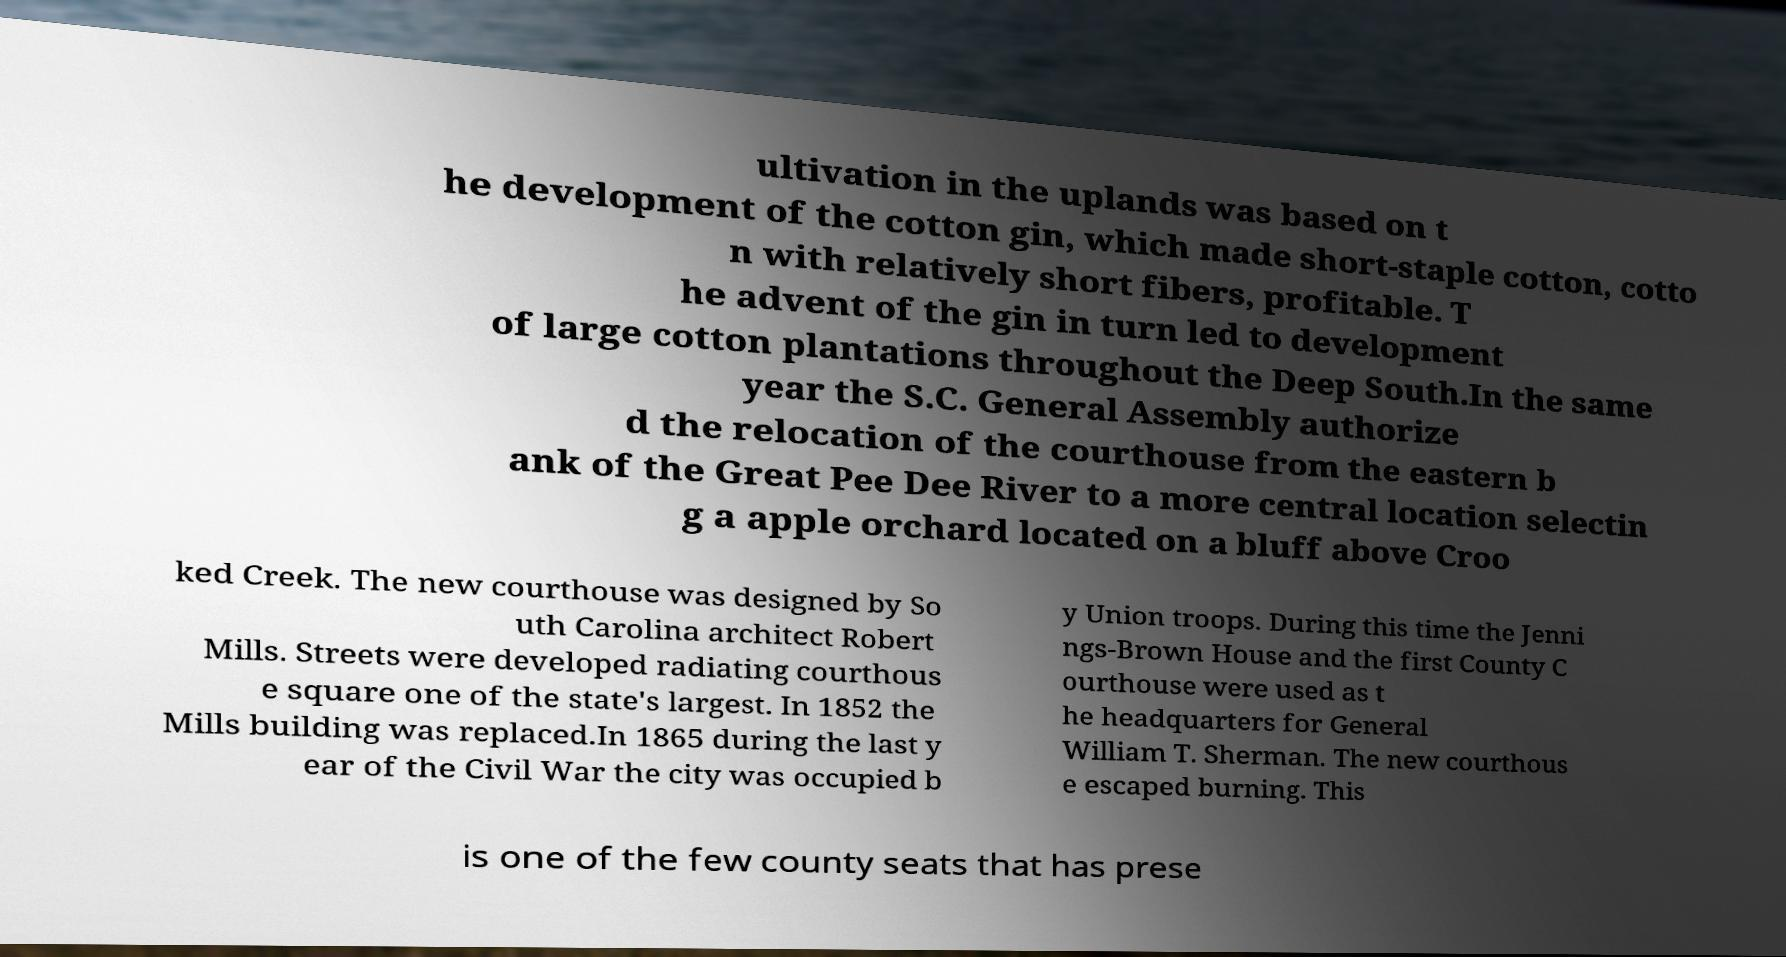What messages or text are displayed in this image? I need them in a readable, typed format. ultivation in the uplands was based on t he development of the cotton gin, which made short-staple cotton, cotto n with relatively short fibers, profitable. T he advent of the gin in turn led to development of large cotton plantations throughout the Deep South.In the same year the S.C. General Assembly authorize d the relocation of the courthouse from the eastern b ank of the Great Pee Dee River to a more central location selectin g a apple orchard located on a bluff above Croo ked Creek. The new courthouse was designed by So uth Carolina architect Robert Mills. Streets were developed radiating courthous e square one of the state's largest. In 1852 the Mills building was replaced.In 1865 during the last y ear of the Civil War the city was occupied b y Union troops. During this time the Jenni ngs-Brown House and the first County C ourthouse were used as t he headquarters for General William T. Sherman. The new courthous e escaped burning. This is one of the few county seats that has prese 